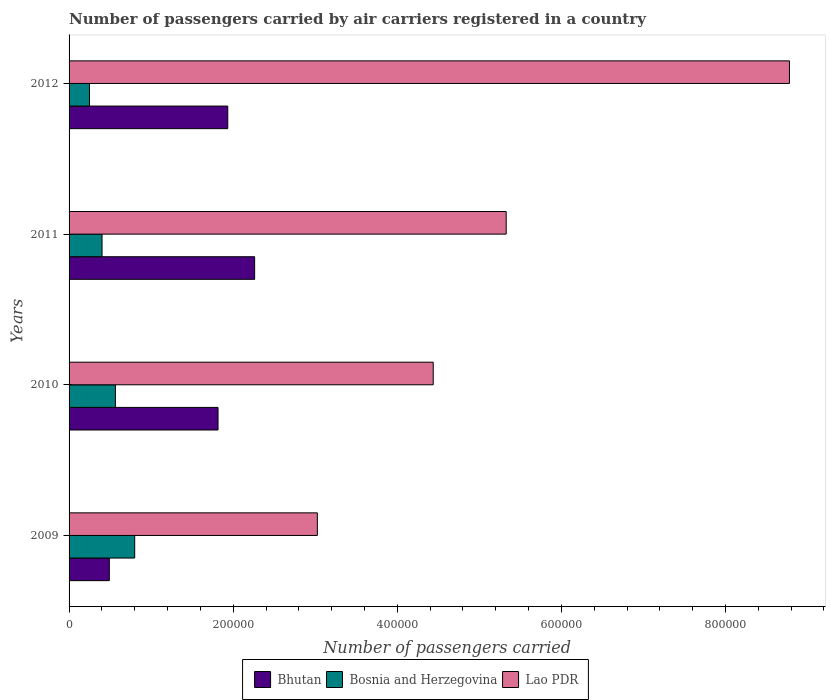How many different coloured bars are there?
Make the answer very short. 3. Are the number of bars per tick equal to the number of legend labels?
Offer a terse response. Yes. What is the label of the 1st group of bars from the top?
Keep it short and to the point. 2012. What is the number of passengers carried by air carriers in Lao PDR in 2010?
Give a very brief answer. 4.44e+05. Across all years, what is the maximum number of passengers carried by air carriers in Bosnia and Herzegovina?
Make the answer very short. 8.00e+04. Across all years, what is the minimum number of passengers carried by air carriers in Bosnia and Herzegovina?
Your answer should be compact. 2.49e+04. In which year was the number of passengers carried by air carriers in Bhutan maximum?
Keep it short and to the point. 2011. In which year was the number of passengers carried by air carriers in Lao PDR minimum?
Make the answer very short. 2009. What is the total number of passengers carried by air carriers in Lao PDR in the graph?
Offer a terse response. 2.16e+06. What is the difference between the number of passengers carried by air carriers in Bosnia and Herzegovina in 2011 and that in 2012?
Provide a short and direct response. 1.53e+04. What is the difference between the number of passengers carried by air carriers in Lao PDR in 2009 and the number of passengers carried by air carriers in Bosnia and Herzegovina in 2011?
Give a very brief answer. 2.62e+05. What is the average number of passengers carried by air carriers in Bhutan per year?
Provide a succinct answer. 1.63e+05. In the year 2011, what is the difference between the number of passengers carried by air carriers in Bosnia and Herzegovina and number of passengers carried by air carriers in Lao PDR?
Provide a short and direct response. -4.93e+05. What is the ratio of the number of passengers carried by air carriers in Bhutan in 2009 to that in 2012?
Make the answer very short. 0.25. Is the number of passengers carried by air carriers in Bhutan in 2009 less than that in 2012?
Provide a short and direct response. Yes. What is the difference between the highest and the second highest number of passengers carried by air carriers in Bhutan?
Offer a terse response. 3.27e+04. What is the difference between the highest and the lowest number of passengers carried by air carriers in Bhutan?
Make the answer very short. 1.77e+05. In how many years, is the number of passengers carried by air carriers in Bhutan greater than the average number of passengers carried by air carriers in Bhutan taken over all years?
Ensure brevity in your answer.  3. Is the sum of the number of passengers carried by air carriers in Bosnia and Herzegovina in 2009 and 2011 greater than the maximum number of passengers carried by air carriers in Bhutan across all years?
Your response must be concise. No. What does the 1st bar from the top in 2011 represents?
Give a very brief answer. Lao PDR. What does the 2nd bar from the bottom in 2011 represents?
Provide a short and direct response. Bosnia and Herzegovina. How many bars are there?
Give a very brief answer. 12. Are all the bars in the graph horizontal?
Offer a very short reply. Yes. How many years are there in the graph?
Keep it short and to the point. 4. What is the difference between two consecutive major ticks on the X-axis?
Your response must be concise. 2.00e+05. Are the values on the major ticks of X-axis written in scientific E-notation?
Your response must be concise. No. Does the graph contain any zero values?
Your answer should be very brief. No. What is the title of the graph?
Keep it short and to the point. Number of passengers carried by air carriers registered in a country. Does "Congo (Republic)" appear as one of the legend labels in the graph?
Give a very brief answer. No. What is the label or title of the X-axis?
Keep it short and to the point. Number of passengers carried. What is the Number of passengers carried in Bhutan in 2009?
Your response must be concise. 4.91e+04. What is the Number of passengers carried in Bosnia and Herzegovina in 2009?
Your answer should be very brief. 8.00e+04. What is the Number of passengers carried in Lao PDR in 2009?
Ensure brevity in your answer.  3.03e+05. What is the Number of passengers carried in Bhutan in 2010?
Ensure brevity in your answer.  1.82e+05. What is the Number of passengers carried of Bosnia and Herzegovina in 2010?
Keep it short and to the point. 5.65e+04. What is the Number of passengers carried in Lao PDR in 2010?
Provide a short and direct response. 4.44e+05. What is the Number of passengers carried in Bhutan in 2011?
Your answer should be compact. 2.26e+05. What is the Number of passengers carried of Bosnia and Herzegovina in 2011?
Your response must be concise. 4.02e+04. What is the Number of passengers carried in Lao PDR in 2011?
Provide a succinct answer. 5.33e+05. What is the Number of passengers carried in Bhutan in 2012?
Your answer should be compact. 1.93e+05. What is the Number of passengers carried of Bosnia and Herzegovina in 2012?
Provide a short and direct response. 2.49e+04. What is the Number of passengers carried of Lao PDR in 2012?
Give a very brief answer. 8.78e+05. Across all years, what is the maximum Number of passengers carried of Bhutan?
Provide a short and direct response. 2.26e+05. Across all years, what is the maximum Number of passengers carried of Bosnia and Herzegovina?
Give a very brief answer. 8.00e+04. Across all years, what is the maximum Number of passengers carried in Lao PDR?
Your answer should be compact. 8.78e+05. Across all years, what is the minimum Number of passengers carried of Bhutan?
Your response must be concise. 4.91e+04. Across all years, what is the minimum Number of passengers carried of Bosnia and Herzegovina?
Provide a succinct answer. 2.49e+04. Across all years, what is the minimum Number of passengers carried of Lao PDR?
Ensure brevity in your answer.  3.03e+05. What is the total Number of passengers carried of Bhutan in the graph?
Offer a terse response. 6.50e+05. What is the total Number of passengers carried in Bosnia and Herzegovina in the graph?
Give a very brief answer. 2.02e+05. What is the total Number of passengers carried in Lao PDR in the graph?
Your answer should be compact. 2.16e+06. What is the difference between the Number of passengers carried of Bhutan in 2009 and that in 2010?
Your response must be concise. -1.32e+05. What is the difference between the Number of passengers carried in Bosnia and Herzegovina in 2009 and that in 2010?
Your answer should be compact. 2.35e+04. What is the difference between the Number of passengers carried in Lao PDR in 2009 and that in 2010?
Your response must be concise. -1.41e+05. What is the difference between the Number of passengers carried in Bhutan in 2009 and that in 2011?
Provide a succinct answer. -1.77e+05. What is the difference between the Number of passengers carried of Bosnia and Herzegovina in 2009 and that in 2011?
Keep it short and to the point. 3.98e+04. What is the difference between the Number of passengers carried in Lao PDR in 2009 and that in 2011?
Your answer should be compact. -2.30e+05. What is the difference between the Number of passengers carried in Bhutan in 2009 and that in 2012?
Provide a succinct answer. -1.44e+05. What is the difference between the Number of passengers carried in Bosnia and Herzegovina in 2009 and that in 2012?
Provide a short and direct response. 5.51e+04. What is the difference between the Number of passengers carried in Lao PDR in 2009 and that in 2012?
Keep it short and to the point. -5.75e+05. What is the difference between the Number of passengers carried in Bhutan in 2010 and that in 2011?
Offer a very short reply. -4.46e+04. What is the difference between the Number of passengers carried in Bosnia and Herzegovina in 2010 and that in 2011?
Your answer should be very brief. 1.63e+04. What is the difference between the Number of passengers carried in Lao PDR in 2010 and that in 2011?
Ensure brevity in your answer.  -8.89e+04. What is the difference between the Number of passengers carried in Bhutan in 2010 and that in 2012?
Provide a succinct answer. -1.19e+04. What is the difference between the Number of passengers carried of Bosnia and Herzegovina in 2010 and that in 2012?
Provide a succinct answer. 3.16e+04. What is the difference between the Number of passengers carried in Lao PDR in 2010 and that in 2012?
Your answer should be compact. -4.34e+05. What is the difference between the Number of passengers carried in Bhutan in 2011 and that in 2012?
Ensure brevity in your answer.  3.27e+04. What is the difference between the Number of passengers carried of Bosnia and Herzegovina in 2011 and that in 2012?
Your response must be concise. 1.53e+04. What is the difference between the Number of passengers carried in Lao PDR in 2011 and that in 2012?
Keep it short and to the point. -3.45e+05. What is the difference between the Number of passengers carried in Bhutan in 2009 and the Number of passengers carried in Bosnia and Herzegovina in 2010?
Provide a short and direct response. -7429.16. What is the difference between the Number of passengers carried of Bhutan in 2009 and the Number of passengers carried of Lao PDR in 2010?
Ensure brevity in your answer.  -3.95e+05. What is the difference between the Number of passengers carried of Bosnia and Herzegovina in 2009 and the Number of passengers carried of Lao PDR in 2010?
Offer a terse response. -3.64e+05. What is the difference between the Number of passengers carried in Bhutan in 2009 and the Number of passengers carried in Bosnia and Herzegovina in 2011?
Provide a succinct answer. 8873.56. What is the difference between the Number of passengers carried in Bhutan in 2009 and the Number of passengers carried in Lao PDR in 2011?
Your answer should be compact. -4.84e+05. What is the difference between the Number of passengers carried of Bosnia and Herzegovina in 2009 and the Number of passengers carried of Lao PDR in 2011?
Your answer should be very brief. -4.53e+05. What is the difference between the Number of passengers carried of Bhutan in 2009 and the Number of passengers carried of Bosnia and Herzegovina in 2012?
Provide a succinct answer. 2.42e+04. What is the difference between the Number of passengers carried in Bhutan in 2009 and the Number of passengers carried in Lao PDR in 2012?
Your answer should be compact. -8.29e+05. What is the difference between the Number of passengers carried of Bosnia and Herzegovina in 2009 and the Number of passengers carried of Lao PDR in 2012?
Give a very brief answer. -7.98e+05. What is the difference between the Number of passengers carried in Bhutan in 2010 and the Number of passengers carried in Bosnia and Herzegovina in 2011?
Ensure brevity in your answer.  1.41e+05. What is the difference between the Number of passengers carried of Bhutan in 2010 and the Number of passengers carried of Lao PDR in 2011?
Provide a short and direct response. -3.51e+05. What is the difference between the Number of passengers carried in Bosnia and Herzegovina in 2010 and the Number of passengers carried in Lao PDR in 2011?
Give a very brief answer. -4.76e+05. What is the difference between the Number of passengers carried of Bhutan in 2010 and the Number of passengers carried of Bosnia and Herzegovina in 2012?
Make the answer very short. 1.57e+05. What is the difference between the Number of passengers carried of Bhutan in 2010 and the Number of passengers carried of Lao PDR in 2012?
Offer a terse response. -6.96e+05. What is the difference between the Number of passengers carried in Bosnia and Herzegovina in 2010 and the Number of passengers carried in Lao PDR in 2012?
Give a very brief answer. -8.21e+05. What is the difference between the Number of passengers carried of Bhutan in 2011 and the Number of passengers carried of Bosnia and Herzegovina in 2012?
Ensure brevity in your answer.  2.01e+05. What is the difference between the Number of passengers carried in Bhutan in 2011 and the Number of passengers carried in Lao PDR in 2012?
Ensure brevity in your answer.  -6.52e+05. What is the difference between the Number of passengers carried in Bosnia and Herzegovina in 2011 and the Number of passengers carried in Lao PDR in 2012?
Your answer should be very brief. -8.38e+05. What is the average Number of passengers carried in Bhutan per year?
Provide a short and direct response. 1.63e+05. What is the average Number of passengers carried of Bosnia and Herzegovina per year?
Your answer should be compact. 5.04e+04. What is the average Number of passengers carried of Lao PDR per year?
Ensure brevity in your answer.  5.39e+05. In the year 2009, what is the difference between the Number of passengers carried in Bhutan and Number of passengers carried in Bosnia and Herzegovina?
Make the answer very short. -3.09e+04. In the year 2009, what is the difference between the Number of passengers carried in Bhutan and Number of passengers carried in Lao PDR?
Give a very brief answer. -2.54e+05. In the year 2009, what is the difference between the Number of passengers carried of Bosnia and Herzegovina and Number of passengers carried of Lao PDR?
Give a very brief answer. -2.23e+05. In the year 2010, what is the difference between the Number of passengers carried of Bhutan and Number of passengers carried of Bosnia and Herzegovina?
Give a very brief answer. 1.25e+05. In the year 2010, what is the difference between the Number of passengers carried of Bhutan and Number of passengers carried of Lao PDR?
Offer a terse response. -2.62e+05. In the year 2010, what is the difference between the Number of passengers carried of Bosnia and Herzegovina and Number of passengers carried of Lao PDR?
Make the answer very short. -3.87e+05. In the year 2011, what is the difference between the Number of passengers carried of Bhutan and Number of passengers carried of Bosnia and Herzegovina?
Your response must be concise. 1.86e+05. In the year 2011, what is the difference between the Number of passengers carried of Bhutan and Number of passengers carried of Lao PDR?
Your answer should be compact. -3.07e+05. In the year 2011, what is the difference between the Number of passengers carried of Bosnia and Herzegovina and Number of passengers carried of Lao PDR?
Provide a short and direct response. -4.93e+05. In the year 2012, what is the difference between the Number of passengers carried in Bhutan and Number of passengers carried in Bosnia and Herzegovina?
Your answer should be compact. 1.69e+05. In the year 2012, what is the difference between the Number of passengers carried in Bhutan and Number of passengers carried in Lao PDR?
Offer a very short reply. -6.85e+05. In the year 2012, what is the difference between the Number of passengers carried of Bosnia and Herzegovina and Number of passengers carried of Lao PDR?
Keep it short and to the point. -8.53e+05. What is the ratio of the Number of passengers carried of Bhutan in 2009 to that in 2010?
Offer a very short reply. 0.27. What is the ratio of the Number of passengers carried of Bosnia and Herzegovina in 2009 to that in 2010?
Ensure brevity in your answer.  1.42. What is the ratio of the Number of passengers carried in Lao PDR in 2009 to that in 2010?
Keep it short and to the point. 0.68. What is the ratio of the Number of passengers carried in Bhutan in 2009 to that in 2011?
Provide a short and direct response. 0.22. What is the ratio of the Number of passengers carried of Bosnia and Herzegovina in 2009 to that in 2011?
Offer a very short reply. 1.99. What is the ratio of the Number of passengers carried of Lao PDR in 2009 to that in 2011?
Your response must be concise. 0.57. What is the ratio of the Number of passengers carried of Bhutan in 2009 to that in 2012?
Provide a short and direct response. 0.25. What is the ratio of the Number of passengers carried of Bosnia and Herzegovina in 2009 to that in 2012?
Your response must be concise. 3.22. What is the ratio of the Number of passengers carried in Lao PDR in 2009 to that in 2012?
Make the answer very short. 0.34. What is the ratio of the Number of passengers carried of Bhutan in 2010 to that in 2011?
Provide a short and direct response. 0.8. What is the ratio of the Number of passengers carried of Bosnia and Herzegovina in 2010 to that in 2011?
Provide a short and direct response. 1.41. What is the ratio of the Number of passengers carried of Lao PDR in 2010 to that in 2011?
Your answer should be compact. 0.83. What is the ratio of the Number of passengers carried of Bhutan in 2010 to that in 2012?
Your response must be concise. 0.94. What is the ratio of the Number of passengers carried in Bosnia and Herzegovina in 2010 to that in 2012?
Offer a terse response. 2.27. What is the ratio of the Number of passengers carried in Lao PDR in 2010 to that in 2012?
Offer a very short reply. 0.51. What is the ratio of the Number of passengers carried of Bhutan in 2011 to that in 2012?
Ensure brevity in your answer.  1.17. What is the ratio of the Number of passengers carried in Bosnia and Herzegovina in 2011 to that in 2012?
Make the answer very short. 1.62. What is the ratio of the Number of passengers carried of Lao PDR in 2011 to that in 2012?
Offer a terse response. 0.61. What is the difference between the highest and the second highest Number of passengers carried of Bhutan?
Your answer should be compact. 3.27e+04. What is the difference between the highest and the second highest Number of passengers carried of Bosnia and Herzegovina?
Your answer should be very brief. 2.35e+04. What is the difference between the highest and the second highest Number of passengers carried of Lao PDR?
Your answer should be compact. 3.45e+05. What is the difference between the highest and the lowest Number of passengers carried in Bhutan?
Provide a short and direct response. 1.77e+05. What is the difference between the highest and the lowest Number of passengers carried of Bosnia and Herzegovina?
Offer a terse response. 5.51e+04. What is the difference between the highest and the lowest Number of passengers carried of Lao PDR?
Offer a terse response. 5.75e+05. 